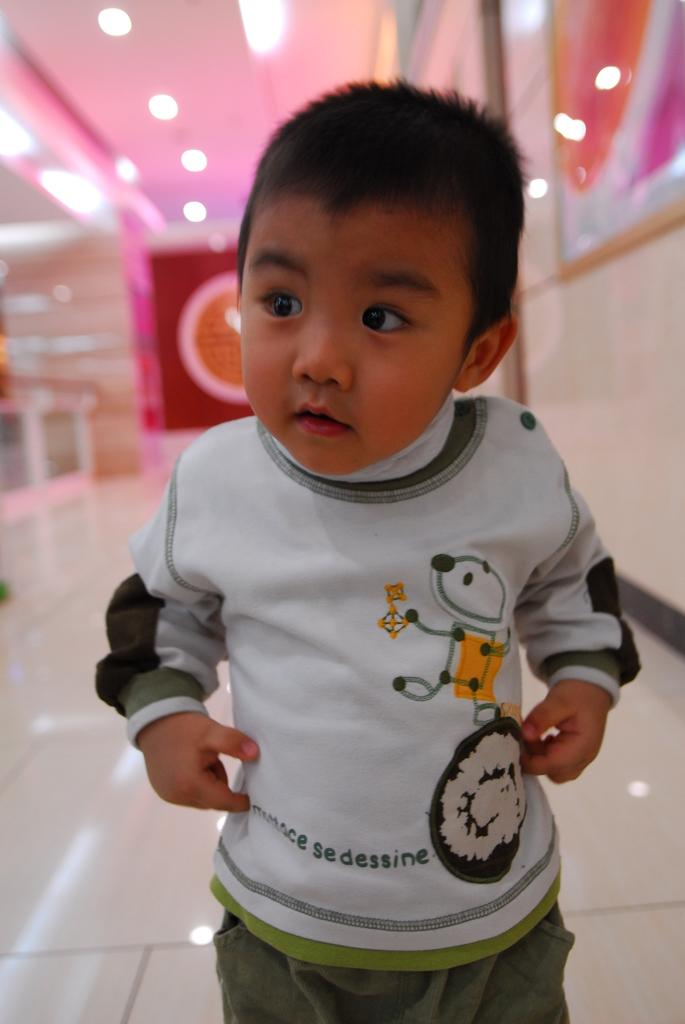What is the main subject of the image? The main subject of the image is a kid. Where is the kid located in the image? The kid is on the floor. What can be seen in the background of the image? There are lights, a ceiling, and a wall visible in the background of the image. Can you see a knot being tied in the image? There is no knot being tied in the image. What type of fiction is the kid reading in the image? The image does not show the kid reading any fiction. 